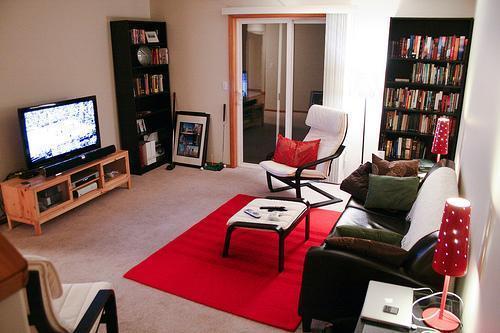How many televisions are there?
Give a very brief answer. 1. 